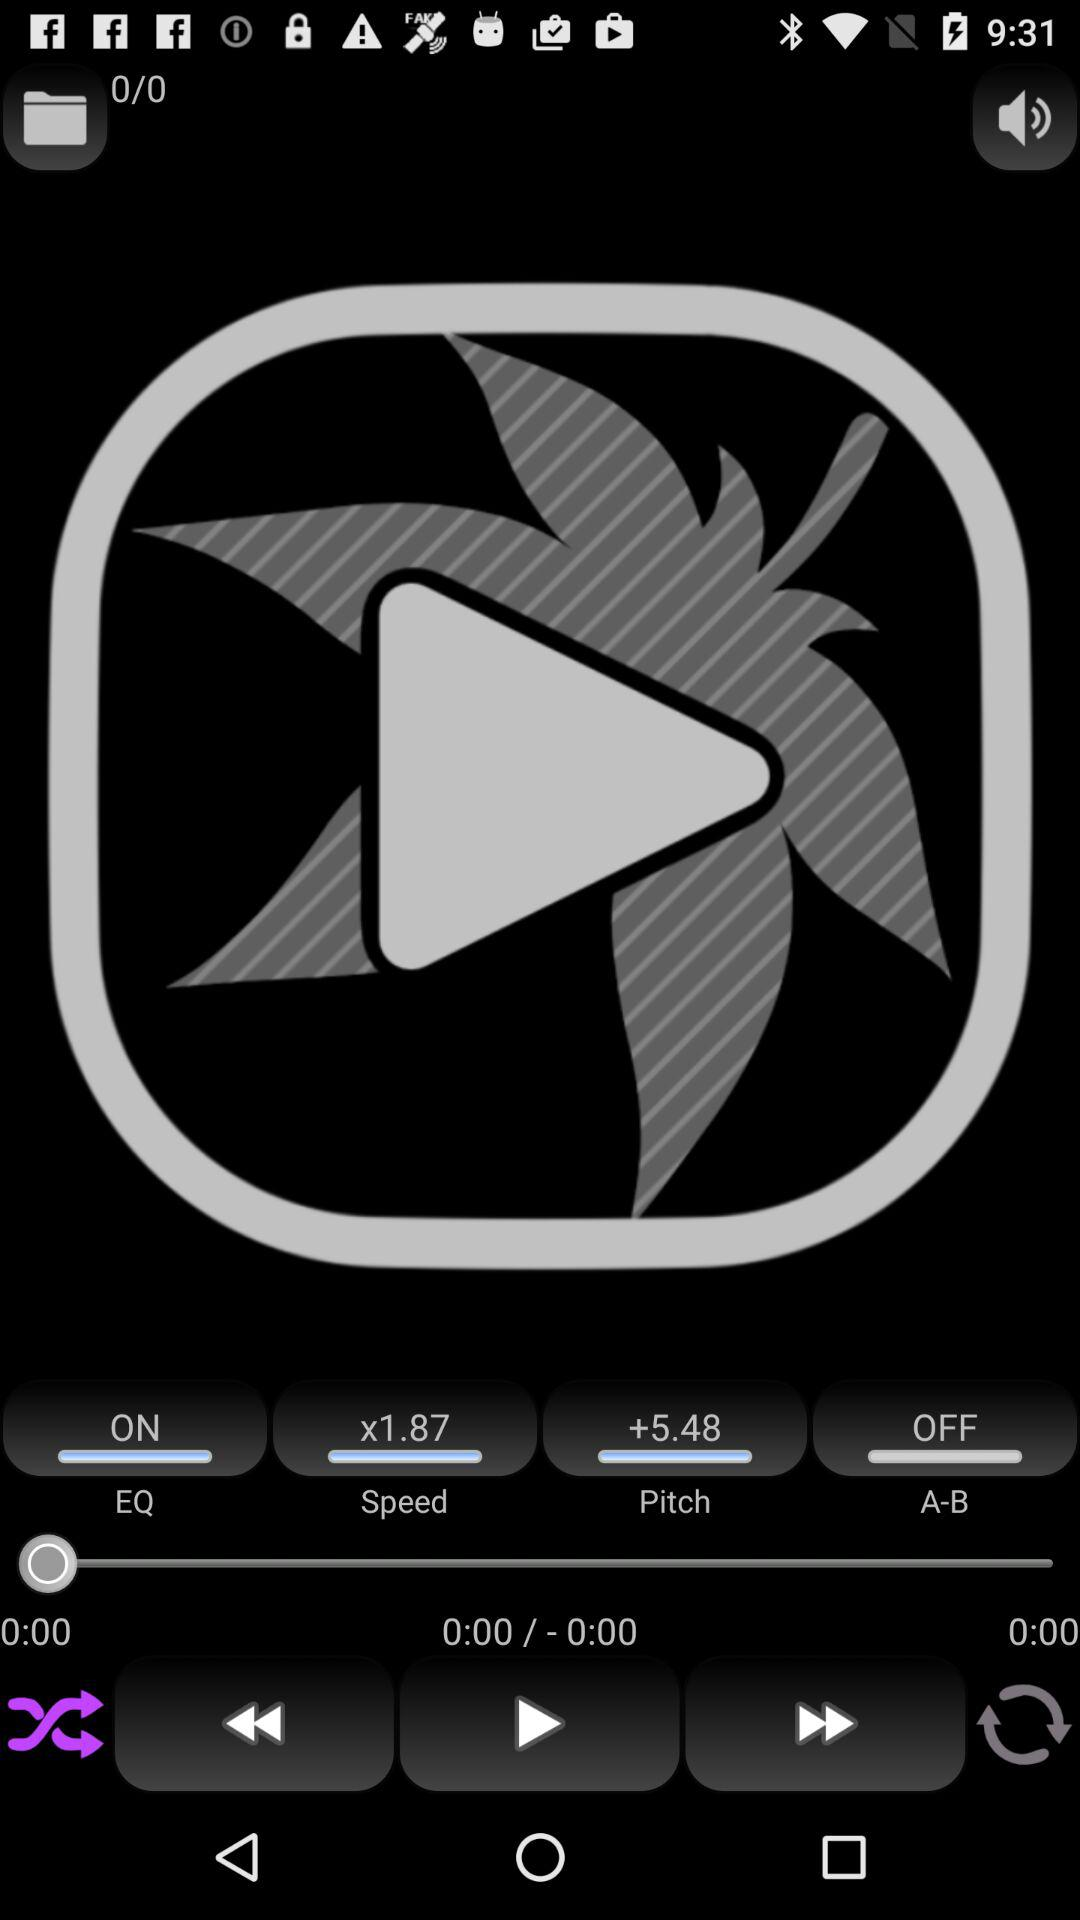What is the speed? The speed is x1.87. 